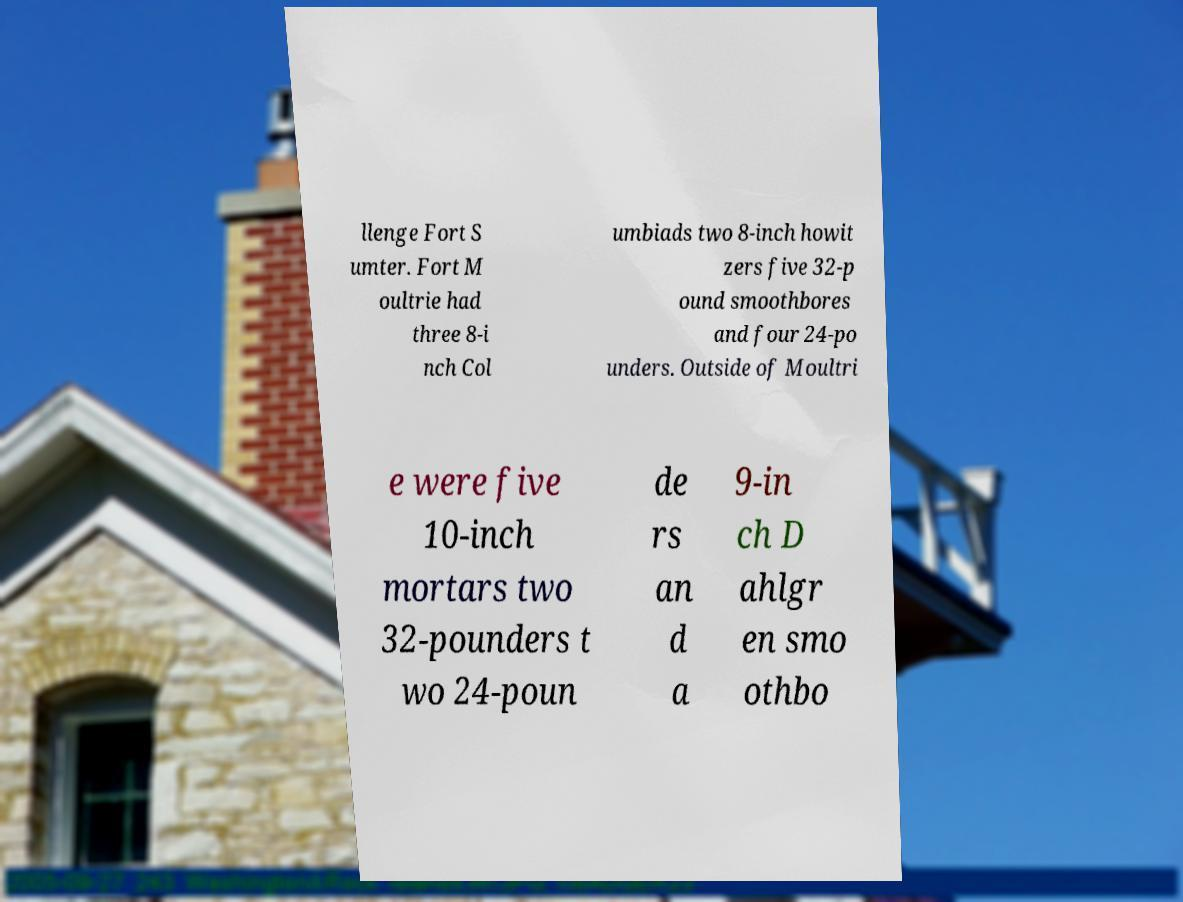Please read and relay the text visible in this image. What does it say? llenge Fort S umter. Fort M oultrie had three 8-i nch Col umbiads two 8-inch howit zers five 32-p ound smoothbores and four 24-po unders. Outside of Moultri e were five 10-inch mortars two 32-pounders t wo 24-poun de rs an d a 9-in ch D ahlgr en smo othbo 